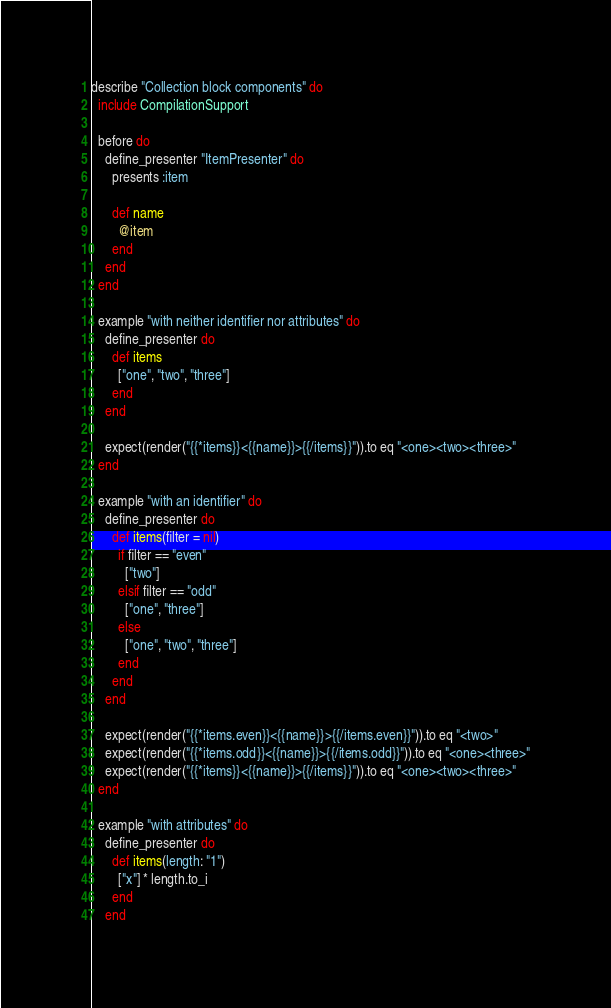Convert code to text. <code><loc_0><loc_0><loc_500><loc_500><_Ruby_>describe "Collection block components" do
  include CompilationSupport

  before do
    define_presenter "ItemPresenter" do
      presents :item

      def name
        @item
      end
    end
  end

  example "with neither identifier nor attributes" do
    define_presenter do
      def items
        ["one", "two", "three"]
      end
    end

    expect(render("{{*items}}<{{name}}>{{/items}}")).to eq "<one><two><three>"
  end

  example "with an identifier" do
    define_presenter do
      def items(filter = nil)
        if filter == "even"
          ["two"]
        elsif filter == "odd"
          ["one", "three"]
        else
          ["one", "two", "three"]
        end
      end
    end

    expect(render("{{*items.even}}<{{name}}>{{/items.even}}")).to eq "<two>"
    expect(render("{{*items.odd}}<{{name}}>{{/items.odd}}")).to eq "<one><three>"
    expect(render("{{*items}}<{{name}}>{{/items}}")).to eq "<one><two><three>"
  end

  example "with attributes" do
    define_presenter do
      def items(length: "1")
        ["x"] * length.to_i
      end
    end
</code> 